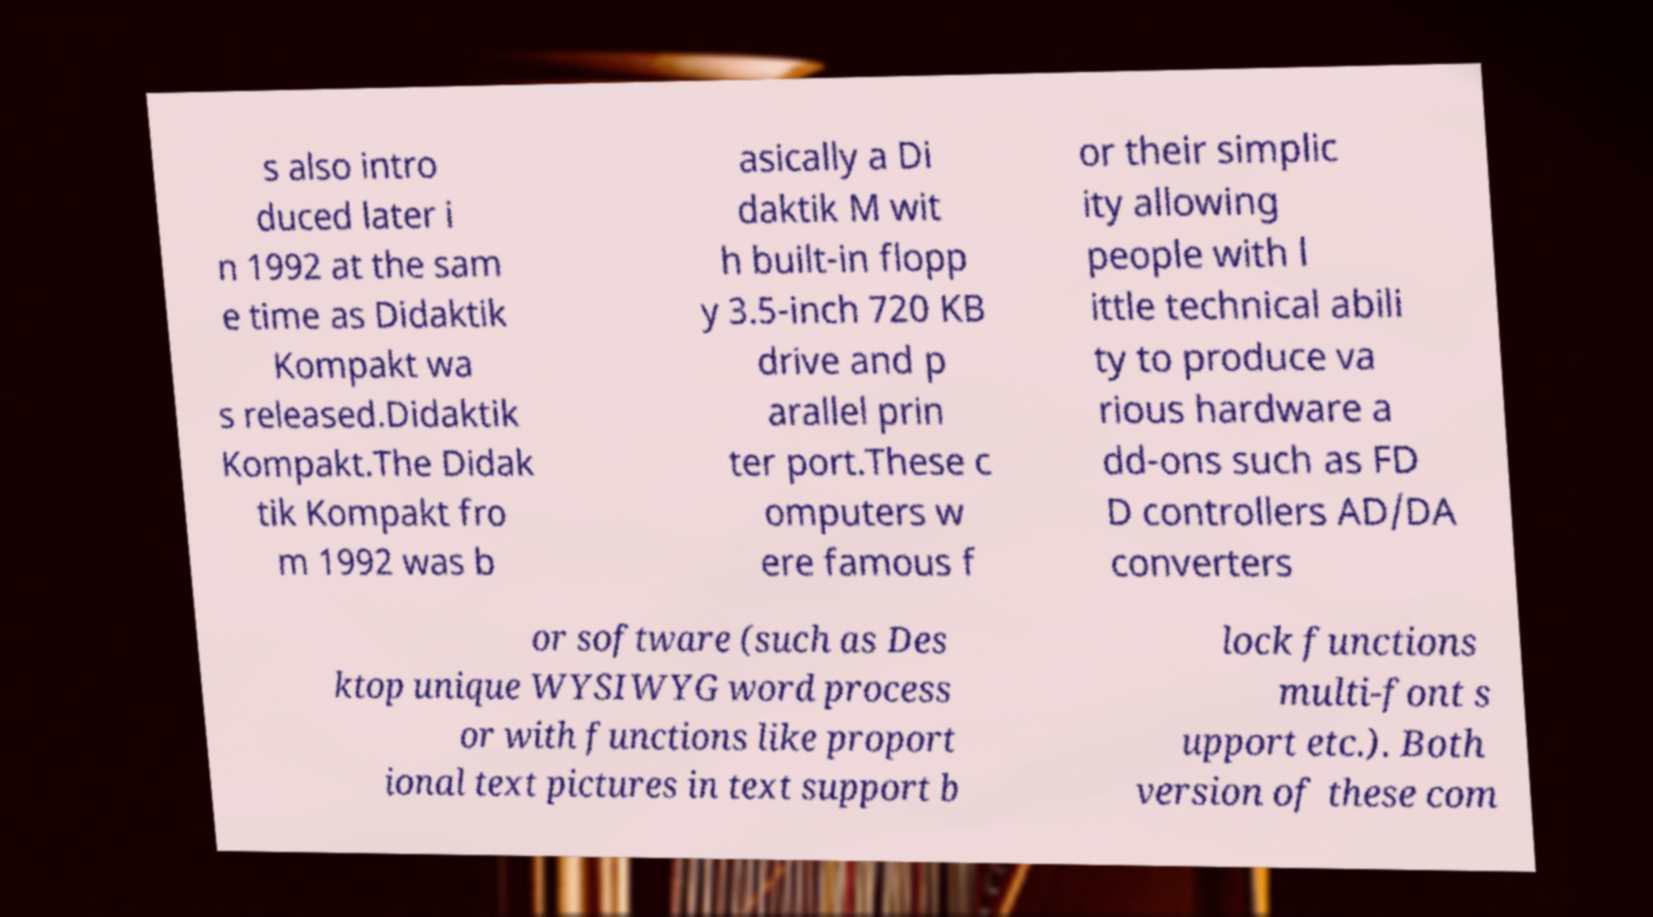Please read and relay the text visible in this image. What does it say? s also intro duced later i n 1992 at the sam e time as Didaktik Kompakt wa s released.Didaktik Kompakt.The Didak tik Kompakt fro m 1992 was b asically a Di daktik M wit h built-in flopp y 3.5-inch 720 KB drive and p arallel prin ter port.These c omputers w ere famous f or their simplic ity allowing people with l ittle technical abili ty to produce va rious hardware a dd-ons such as FD D controllers AD/DA converters or software (such as Des ktop unique WYSIWYG word process or with functions like proport ional text pictures in text support b lock functions multi-font s upport etc.). Both version of these com 